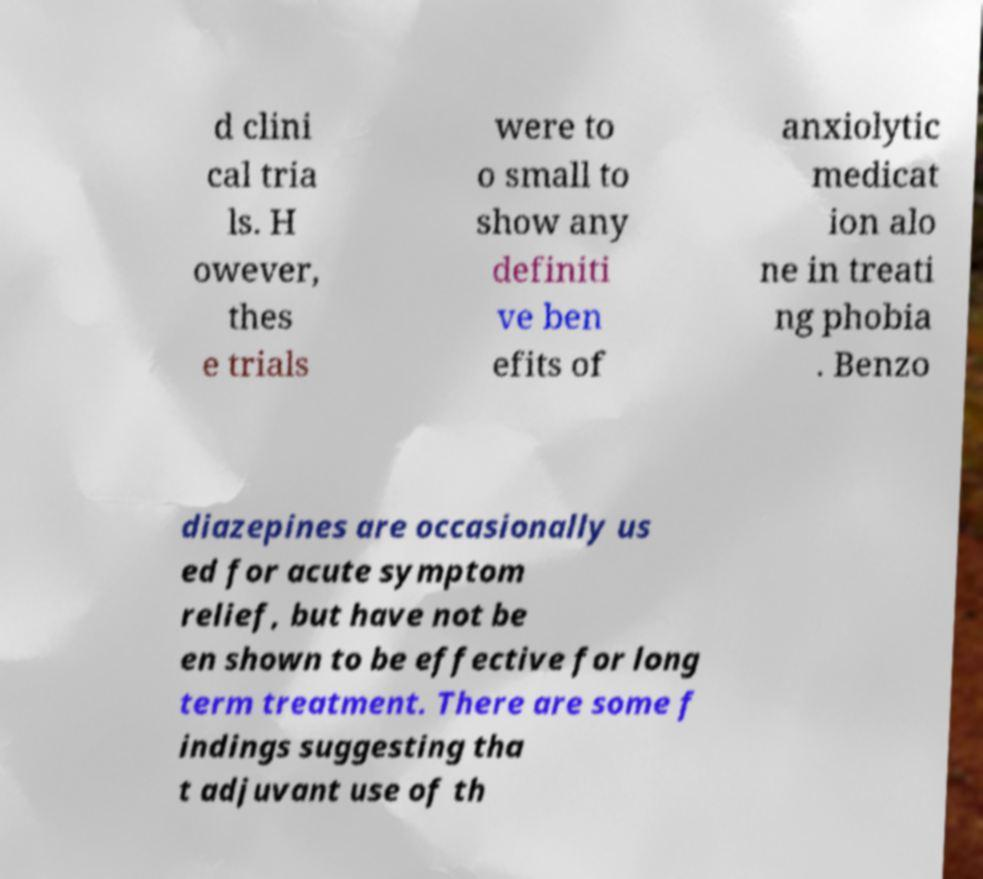Please read and relay the text visible in this image. What does it say? d clini cal tria ls. H owever, thes e trials were to o small to show any definiti ve ben efits of anxiolytic medicat ion alo ne in treati ng phobia . Benzo diazepines are occasionally us ed for acute symptom relief, but have not be en shown to be effective for long term treatment. There are some f indings suggesting tha t adjuvant use of th 